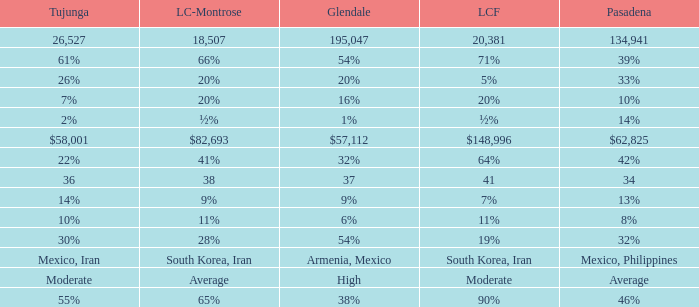When La Crescenta-Montrose has 66%, what is Tujunga? 61%. 